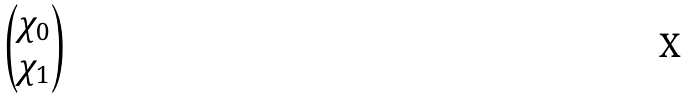Convert formula to latex. <formula><loc_0><loc_0><loc_500><loc_500>\begin{pmatrix} \chi _ { 0 } \\ \chi _ { 1 } \end{pmatrix}</formula> 